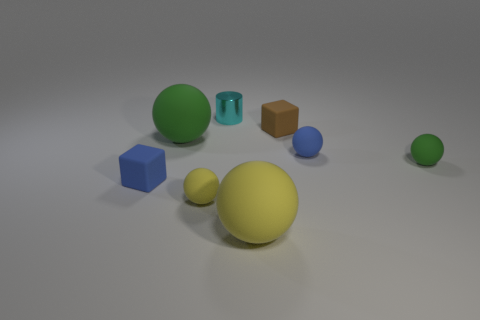Subtract all tiny blue balls. How many balls are left? 4 Add 1 small blue matte spheres. How many objects exist? 9 Subtract all blue spheres. How many spheres are left? 4 Subtract 2 spheres. How many spheres are left? 3 Add 6 big green metal blocks. How many big green metal blocks exist? 6 Subtract 0 gray cylinders. How many objects are left? 8 Subtract all blocks. How many objects are left? 6 Subtract all yellow blocks. Subtract all green cylinders. How many blocks are left? 2 Subtract all green cylinders. How many cyan blocks are left? 0 Subtract all large green metallic cubes. Subtract all brown matte things. How many objects are left? 7 